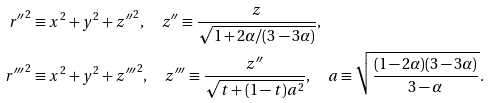<formula> <loc_0><loc_0><loc_500><loc_500>r { ^ { \prime \prime } } ^ { 2 } & \equiv x ^ { 2 } + y ^ { 2 } + z { ^ { \prime \prime } } ^ { 2 } , \quad z { ^ { \prime \prime } } \equiv \frac { z } { \sqrt { 1 + 2 \alpha / ( 3 - 3 \alpha ) } } , \\ r { ^ { \prime \prime \prime } } ^ { 2 } & \equiv x ^ { 2 } + y ^ { 2 } + z { ^ { \prime \prime \prime } } ^ { 2 } , \quad z { ^ { \prime \prime \prime } } \equiv \frac { z { ^ { \prime \prime } } } { \sqrt { t + ( 1 - t ) a ^ { 2 } } } , \quad a \equiv \sqrt { \frac { ( 1 - 2 \alpha ) ( 3 - 3 \alpha ) } { 3 - \alpha } } .</formula> 